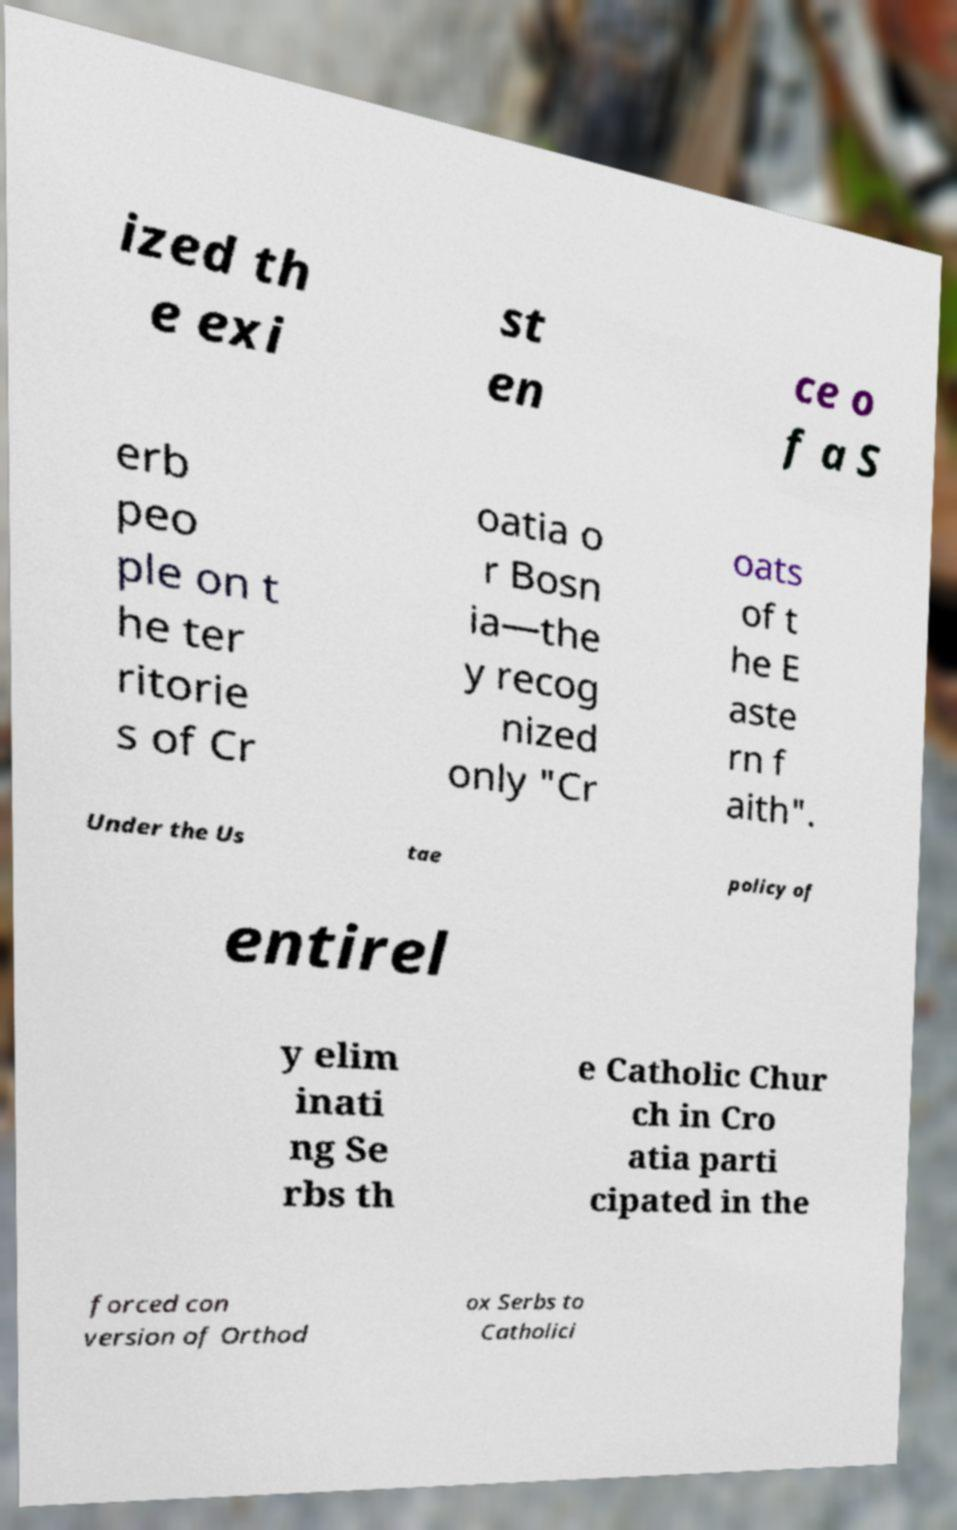Could you extract and type out the text from this image? ized th e exi st en ce o f a S erb peo ple on t he ter ritorie s of Cr oatia o r Bosn ia—the y recog nized only "Cr oats of t he E aste rn f aith". Under the Us tae policy of entirel y elim inati ng Se rbs th e Catholic Chur ch in Cro atia parti cipated in the forced con version of Orthod ox Serbs to Catholici 